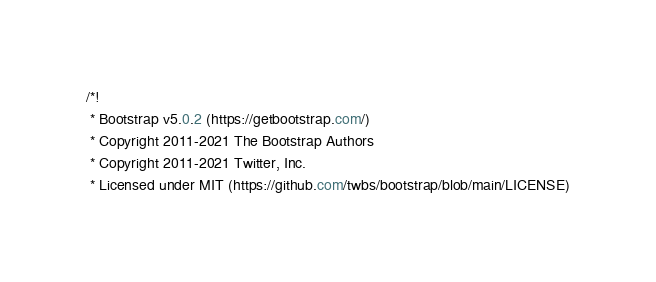<code> <loc_0><loc_0><loc_500><loc_500><_CSS_>/*!
 * Bootstrap v5.0.2 (https://getbootstrap.com/)
 * Copyright 2011-2021 The Bootstrap Authors
 * Copyright 2011-2021 Twitter, Inc.
 * Licensed under MIT (https://github.com/twbs/bootstrap/blob/main/LICENSE)</code> 